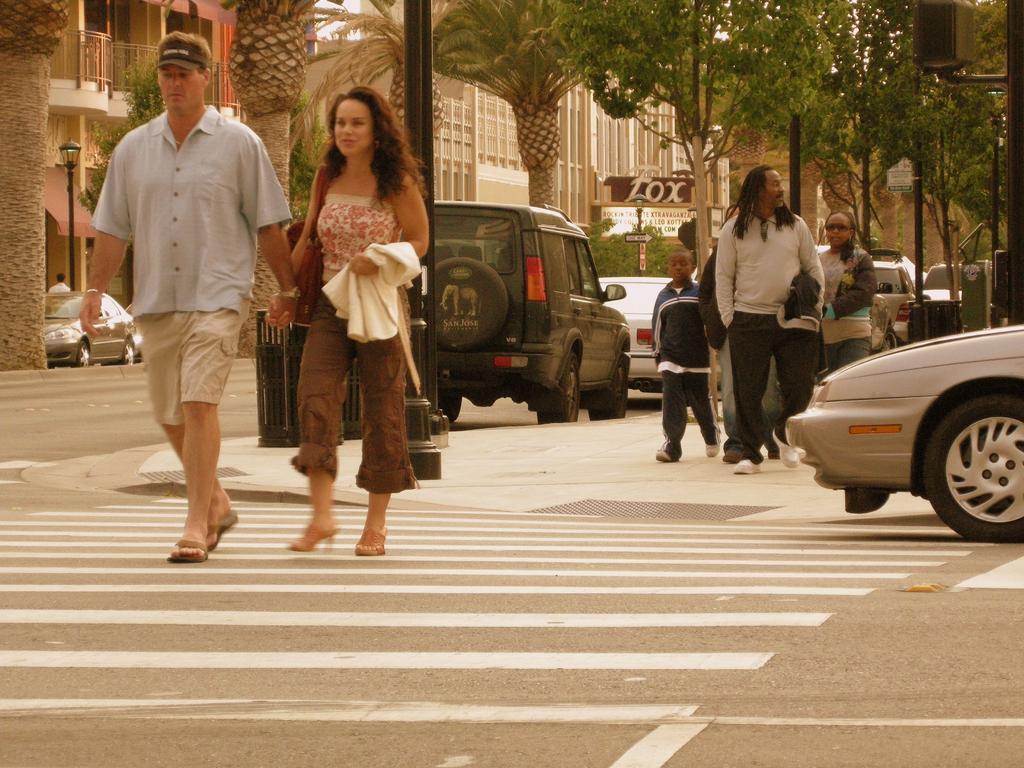Can you describe this image briefly? In this picture we can observe some people walking on the footpath. There is a couple walking on the zebra crossing. On the right side we can observe a car. In the background there are some cars on the road. We can observe trees, poles and buildings in this picture. 